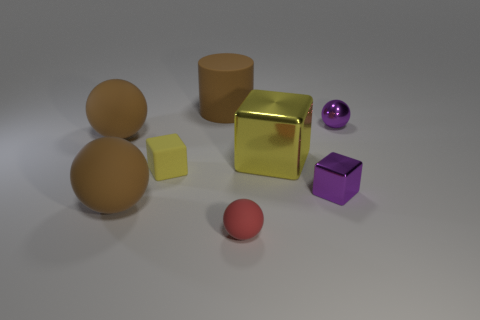There is a large metal object that is the same color as the small rubber block; what shape is it?
Provide a short and direct response. Cube. There is a metallic thing that is the same color as the small rubber cube; what is its size?
Your answer should be very brief. Large. What number of small matte cubes have the same color as the large cube?
Your answer should be compact. 1. There is a purple object behind the tiny yellow matte thing; how big is it?
Offer a very short reply. Small. What number of blue objects are either large rubber spheres or large objects?
Your answer should be compact. 0. Are there any metallic spheres of the same size as the purple shiny cube?
Make the answer very short. Yes. There is another ball that is the same size as the red sphere; what material is it?
Make the answer very short. Metal. There is a cube to the left of the red object; does it have the same size as the yellow block that is on the right side of the big cylinder?
Keep it short and to the point. No. What number of things are either small purple things or brown matte things that are left of the cylinder?
Provide a succinct answer. 4. Are there any other rubber things that have the same shape as the small yellow rubber thing?
Your answer should be compact. No. 